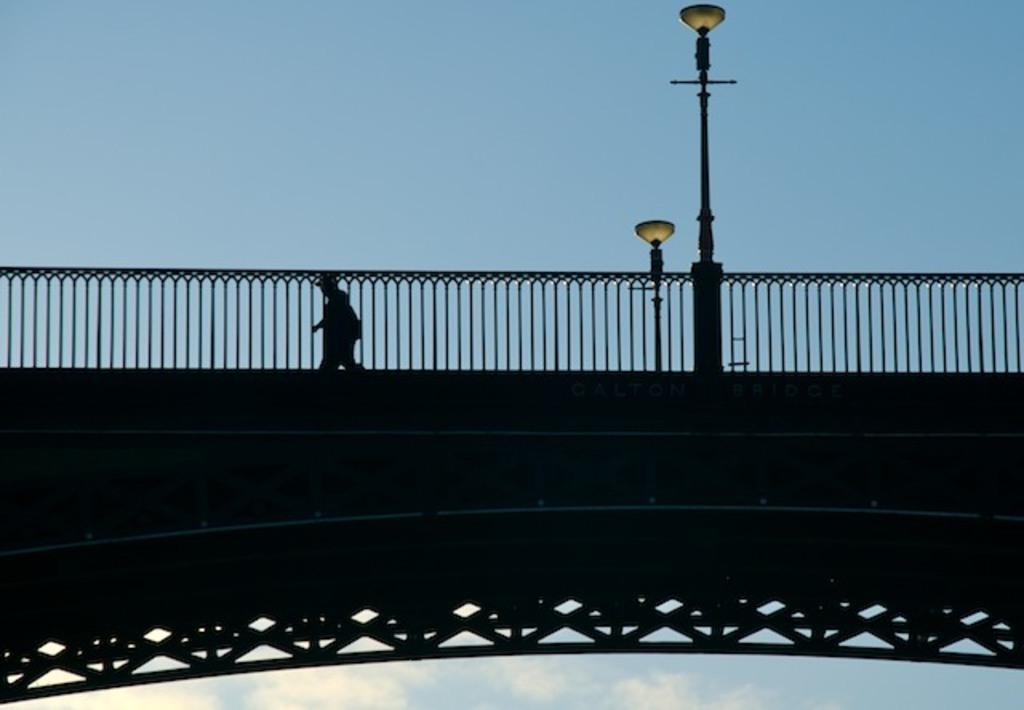What structure is present in the image? There is a bridge in the image. What feature can be seen on the bridge? The bridge has street lights. What is the person in the image doing? A person is walking behind a fence. What can be seen in the background of the image? The sky is visible in the background of the image. What is the condition of the sky in the image? There are clouds in the sky. How many rabbits can be seen hopping on the bridge in the image? There are no rabbits present in the image; it features a bridge with a person walking behind a fence. What type of cherry is growing on the bridge in the image? There is no cherry plant or fruit present on the bridge in the image. 